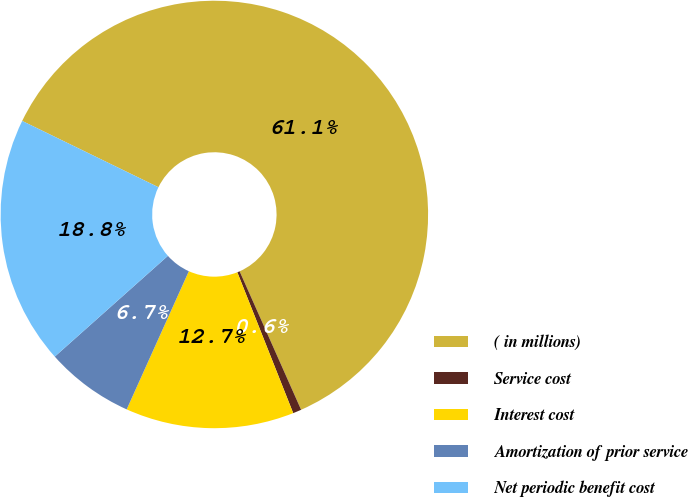Convert chart. <chart><loc_0><loc_0><loc_500><loc_500><pie_chart><fcel>( in millions)<fcel>Service cost<fcel>Interest cost<fcel>Amortization of prior service<fcel>Net periodic benefit cost<nl><fcel>61.14%<fcel>0.64%<fcel>12.74%<fcel>6.69%<fcel>18.79%<nl></chart> 